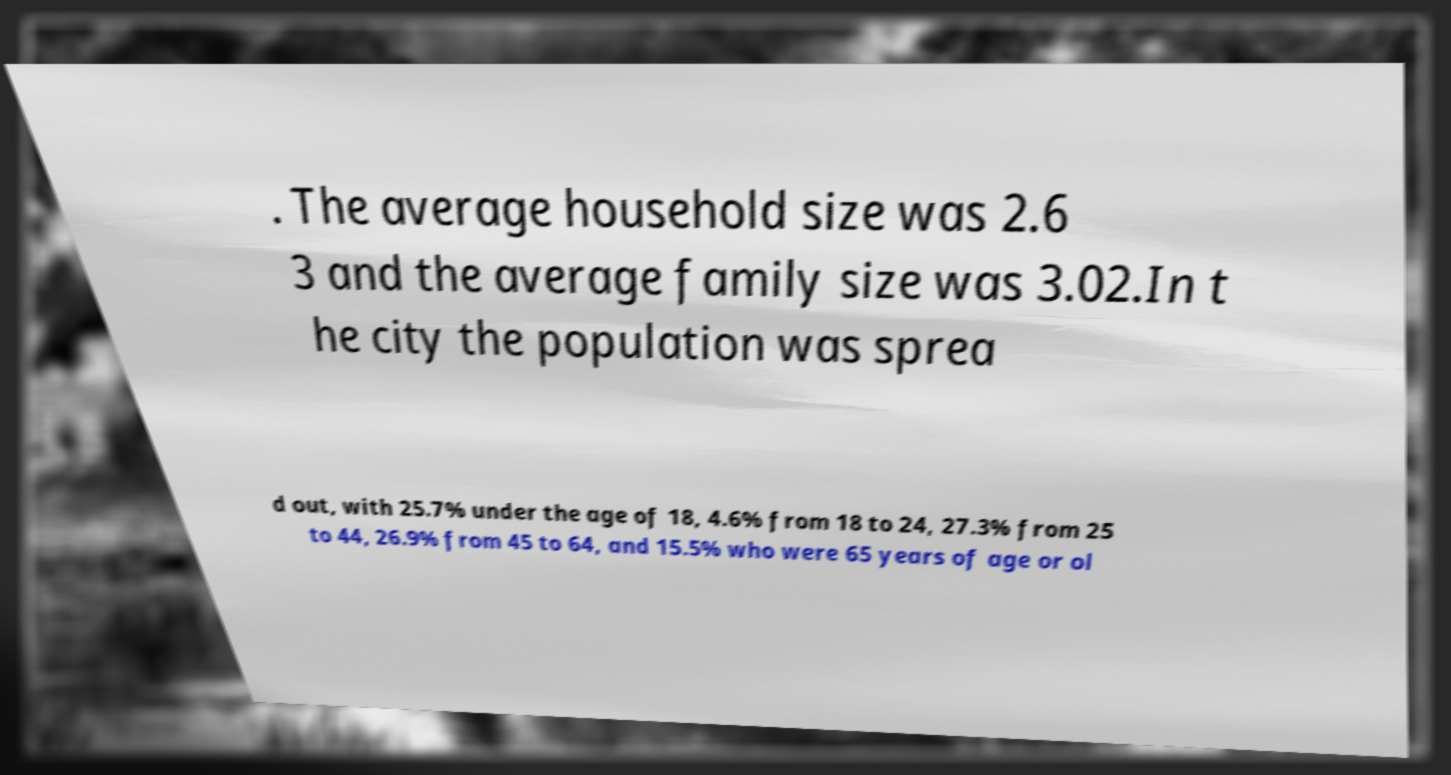What messages or text are displayed in this image? I need them in a readable, typed format. . The average household size was 2.6 3 and the average family size was 3.02.In t he city the population was sprea d out, with 25.7% under the age of 18, 4.6% from 18 to 24, 27.3% from 25 to 44, 26.9% from 45 to 64, and 15.5% who were 65 years of age or ol 